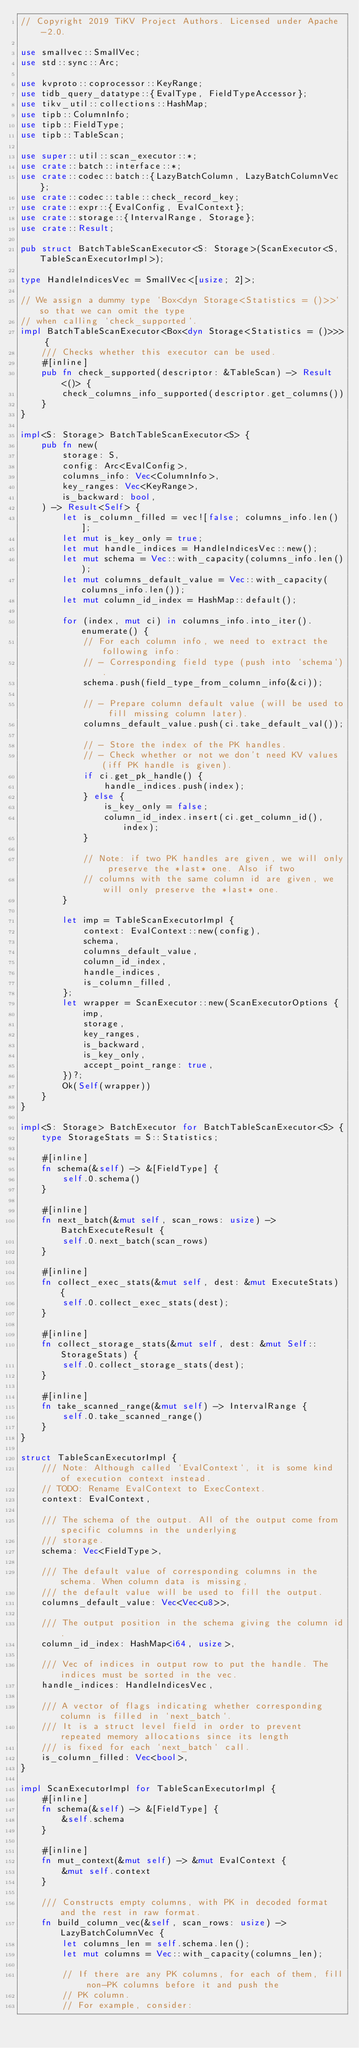<code> <loc_0><loc_0><loc_500><loc_500><_Rust_>// Copyright 2019 TiKV Project Authors. Licensed under Apache-2.0.

use smallvec::SmallVec;
use std::sync::Arc;

use kvproto::coprocessor::KeyRange;
use tidb_query_datatype::{EvalType, FieldTypeAccessor};
use tikv_util::collections::HashMap;
use tipb::ColumnInfo;
use tipb::FieldType;
use tipb::TableScan;

use super::util::scan_executor::*;
use crate::batch::interface::*;
use crate::codec::batch::{LazyBatchColumn, LazyBatchColumnVec};
use crate::codec::table::check_record_key;
use crate::expr::{EvalConfig, EvalContext};
use crate::storage::{IntervalRange, Storage};
use crate::Result;

pub struct BatchTableScanExecutor<S: Storage>(ScanExecutor<S, TableScanExecutorImpl>);

type HandleIndicesVec = SmallVec<[usize; 2]>;

// We assign a dummy type `Box<dyn Storage<Statistics = ()>>` so that we can omit the type
// when calling `check_supported`.
impl BatchTableScanExecutor<Box<dyn Storage<Statistics = ()>>> {
    /// Checks whether this executor can be used.
    #[inline]
    pub fn check_supported(descriptor: &TableScan) -> Result<()> {
        check_columns_info_supported(descriptor.get_columns())
    }
}

impl<S: Storage> BatchTableScanExecutor<S> {
    pub fn new(
        storage: S,
        config: Arc<EvalConfig>,
        columns_info: Vec<ColumnInfo>,
        key_ranges: Vec<KeyRange>,
        is_backward: bool,
    ) -> Result<Self> {
        let is_column_filled = vec![false; columns_info.len()];
        let mut is_key_only = true;
        let mut handle_indices = HandleIndicesVec::new();
        let mut schema = Vec::with_capacity(columns_info.len());
        let mut columns_default_value = Vec::with_capacity(columns_info.len());
        let mut column_id_index = HashMap::default();

        for (index, mut ci) in columns_info.into_iter().enumerate() {
            // For each column info, we need to extract the following info:
            // - Corresponding field type (push into `schema`).
            schema.push(field_type_from_column_info(&ci));

            // - Prepare column default value (will be used to fill missing column later).
            columns_default_value.push(ci.take_default_val());

            // - Store the index of the PK handles.
            // - Check whether or not we don't need KV values (iff PK handle is given).
            if ci.get_pk_handle() {
                handle_indices.push(index);
            } else {
                is_key_only = false;
                column_id_index.insert(ci.get_column_id(), index);
            }

            // Note: if two PK handles are given, we will only preserve the *last* one. Also if two
            // columns with the same column id are given, we will only preserve the *last* one.
        }

        let imp = TableScanExecutorImpl {
            context: EvalContext::new(config),
            schema,
            columns_default_value,
            column_id_index,
            handle_indices,
            is_column_filled,
        };
        let wrapper = ScanExecutor::new(ScanExecutorOptions {
            imp,
            storage,
            key_ranges,
            is_backward,
            is_key_only,
            accept_point_range: true,
        })?;
        Ok(Self(wrapper))
    }
}

impl<S: Storage> BatchExecutor for BatchTableScanExecutor<S> {
    type StorageStats = S::Statistics;

    #[inline]
    fn schema(&self) -> &[FieldType] {
        self.0.schema()
    }

    #[inline]
    fn next_batch(&mut self, scan_rows: usize) -> BatchExecuteResult {
        self.0.next_batch(scan_rows)
    }

    #[inline]
    fn collect_exec_stats(&mut self, dest: &mut ExecuteStats) {
        self.0.collect_exec_stats(dest);
    }

    #[inline]
    fn collect_storage_stats(&mut self, dest: &mut Self::StorageStats) {
        self.0.collect_storage_stats(dest);
    }

    #[inline]
    fn take_scanned_range(&mut self) -> IntervalRange {
        self.0.take_scanned_range()
    }
}

struct TableScanExecutorImpl {
    /// Note: Although called `EvalContext`, it is some kind of execution context instead.
    // TODO: Rename EvalContext to ExecContext.
    context: EvalContext,

    /// The schema of the output. All of the output come from specific columns in the underlying
    /// storage.
    schema: Vec<FieldType>,

    /// The default value of corresponding columns in the schema. When column data is missing,
    /// the default value will be used to fill the output.
    columns_default_value: Vec<Vec<u8>>,

    /// The output position in the schema giving the column id.
    column_id_index: HashMap<i64, usize>,

    /// Vec of indices in output row to put the handle. The indices must be sorted in the vec.
    handle_indices: HandleIndicesVec,

    /// A vector of flags indicating whether corresponding column is filled in `next_batch`.
    /// It is a struct level field in order to prevent repeated memory allocations since its length
    /// is fixed for each `next_batch` call.
    is_column_filled: Vec<bool>,
}

impl ScanExecutorImpl for TableScanExecutorImpl {
    #[inline]
    fn schema(&self) -> &[FieldType] {
        &self.schema
    }

    #[inline]
    fn mut_context(&mut self) -> &mut EvalContext {
        &mut self.context
    }

    /// Constructs empty columns, with PK in decoded format and the rest in raw format.
    fn build_column_vec(&self, scan_rows: usize) -> LazyBatchColumnVec {
        let columns_len = self.schema.len();
        let mut columns = Vec::with_capacity(columns_len);

        // If there are any PK columns, for each of them, fill non-PK columns before it and push the
        // PK column.
        // For example, consider:</code> 